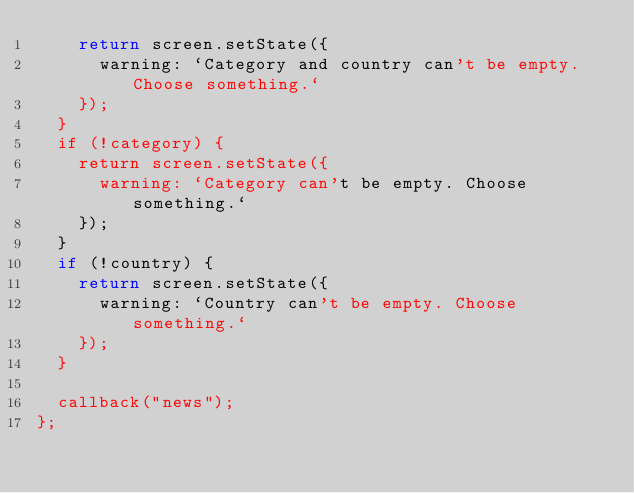<code> <loc_0><loc_0><loc_500><loc_500><_JavaScript_>    return screen.setState({
      warning: `Category and country can't be empty. Choose something.`
    });
  }
  if (!category) {
    return screen.setState({
      warning: `Category can't be empty. Choose something.`
    });
  }
  if (!country) {
    return screen.setState({
      warning: `Country can't be empty. Choose something.`
    });
  }

  callback("news");
};
</code> 